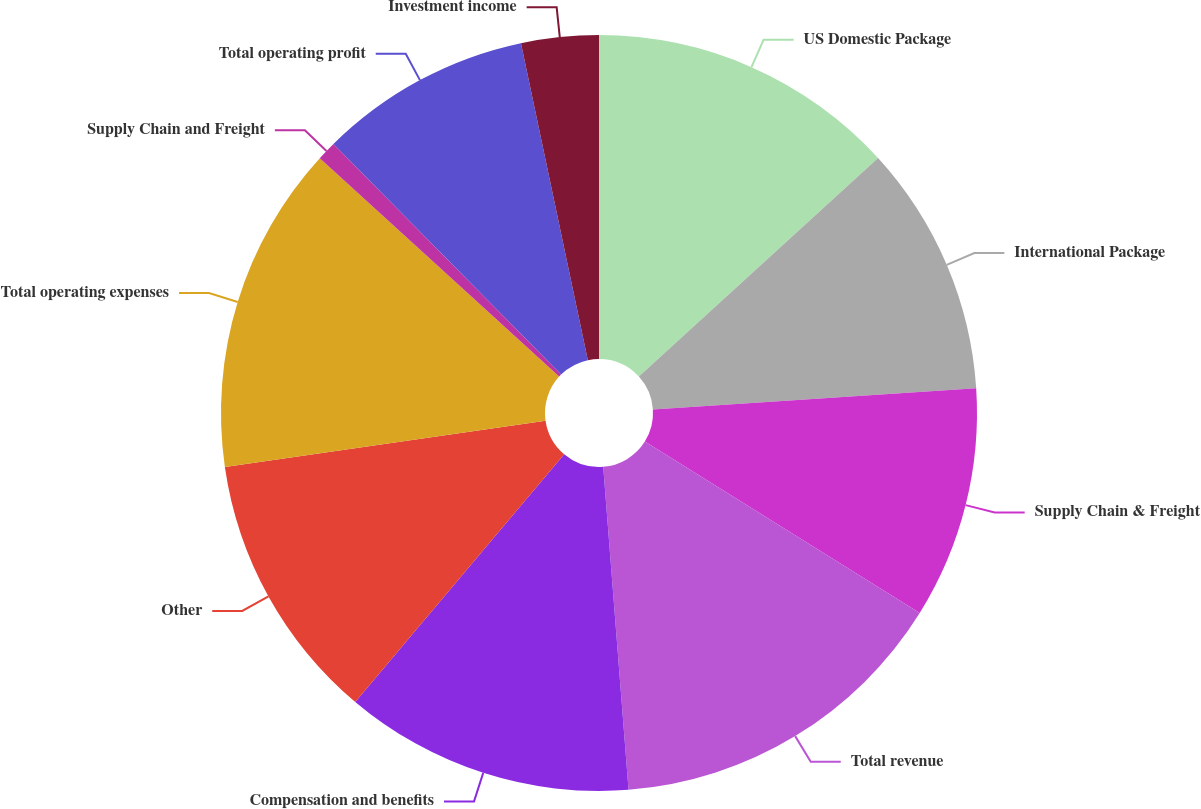<chart> <loc_0><loc_0><loc_500><loc_500><pie_chart><fcel>US Domestic Package<fcel>International Package<fcel>Supply Chain & Freight<fcel>Total revenue<fcel>Compensation and benefits<fcel>Other<fcel>Total operating expenses<fcel>Supply Chain and Freight<fcel>Total operating profit<fcel>Investment income<nl><fcel>13.22%<fcel>10.74%<fcel>9.92%<fcel>14.88%<fcel>12.4%<fcel>11.57%<fcel>14.05%<fcel>0.83%<fcel>9.09%<fcel>3.31%<nl></chart> 